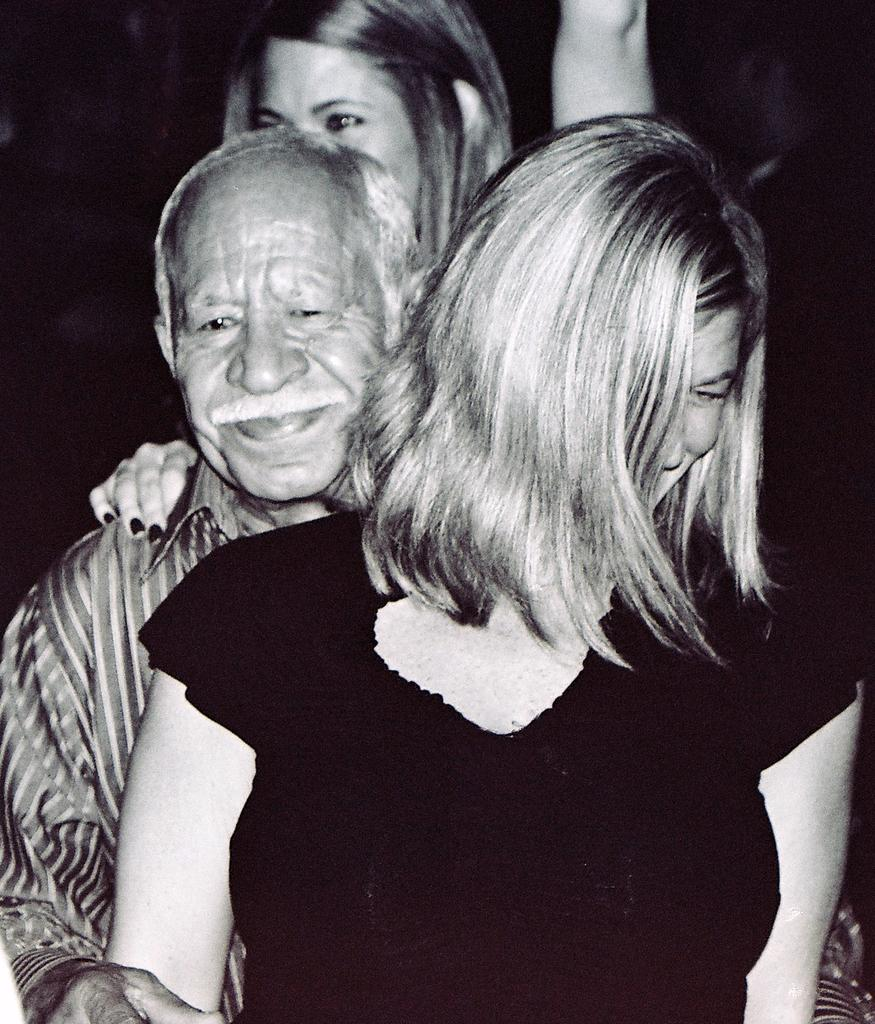How many people are in the image? There are three persons in the image. What are the persons doing in the image? The persons are standing and smiling. What is the color scheme of the image? The image is in black and white. What can be observed about the background of the image? The background of the image is dark. What size of sail can be seen in the image? There is no sail present in the image. What is the surprise element in the image? There is no surprise element in the image; it features three persons standing and smiling. 